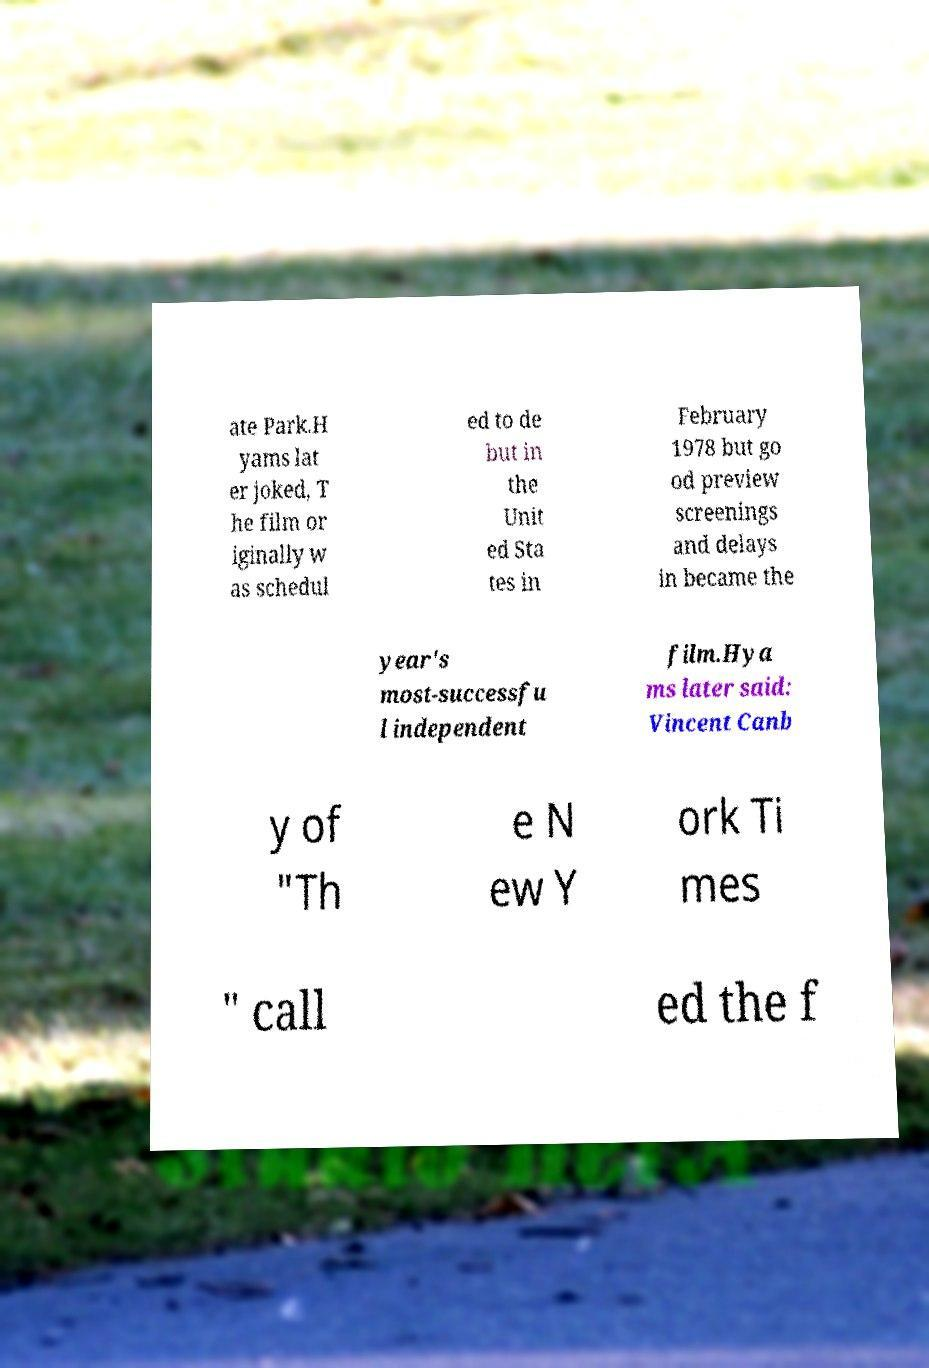I need the written content from this picture converted into text. Can you do that? ate Park.H yams lat er joked, T he film or iginally w as schedul ed to de but in the Unit ed Sta tes in February 1978 but go od preview screenings and delays in became the year's most-successfu l independent film.Hya ms later said: Vincent Canb y of "Th e N ew Y ork Ti mes " call ed the f 